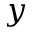Convert formula to latex. <formula><loc_0><loc_0><loc_500><loc_500>y</formula> 